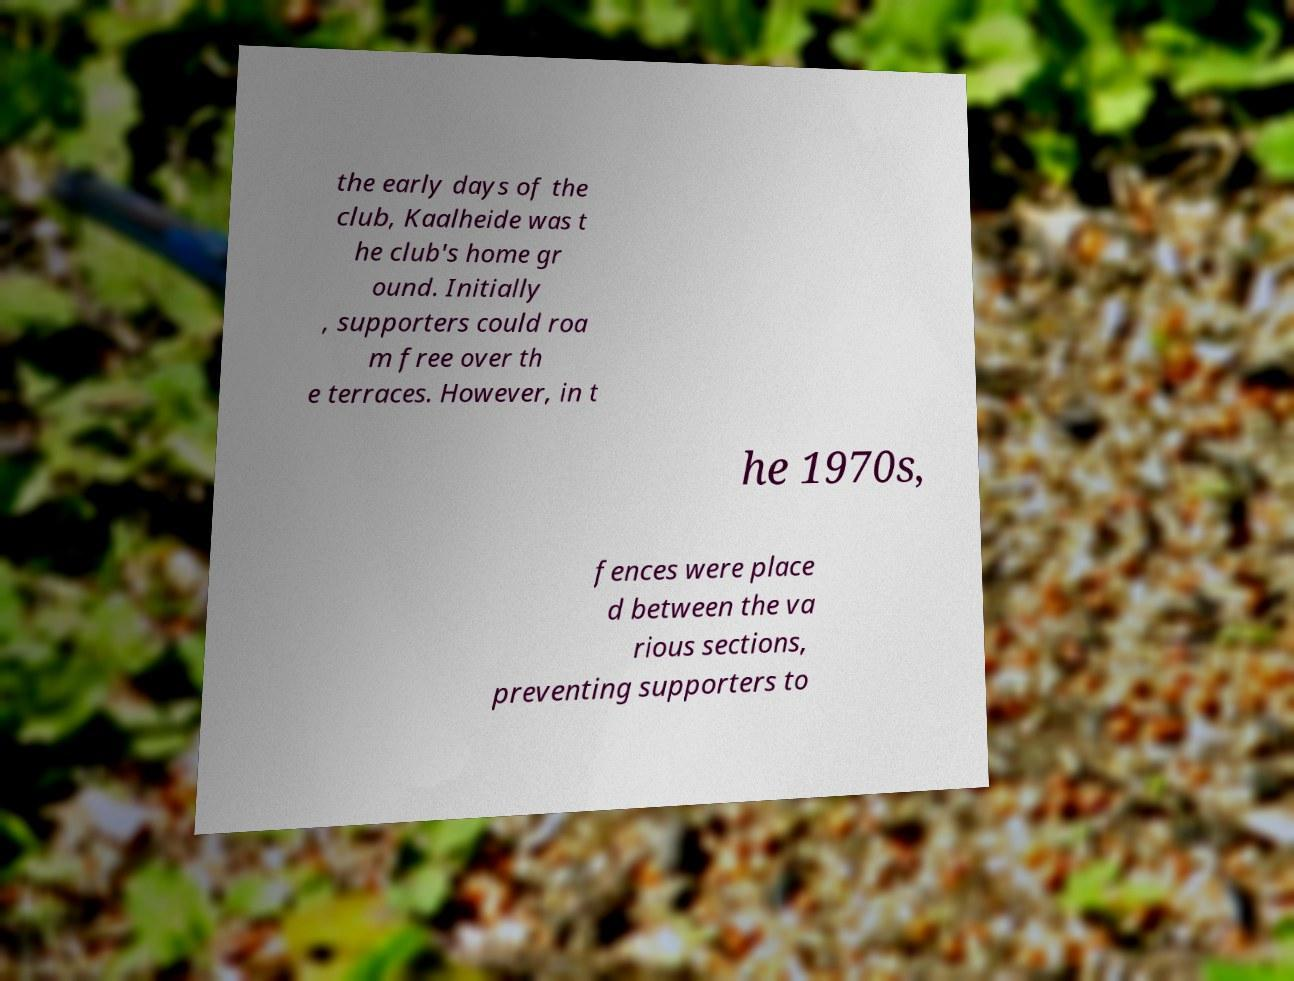Can you accurately transcribe the text from the provided image for me? the early days of the club, Kaalheide was t he club's home gr ound. Initially , supporters could roa m free over th e terraces. However, in t he 1970s, fences were place d between the va rious sections, preventing supporters to 